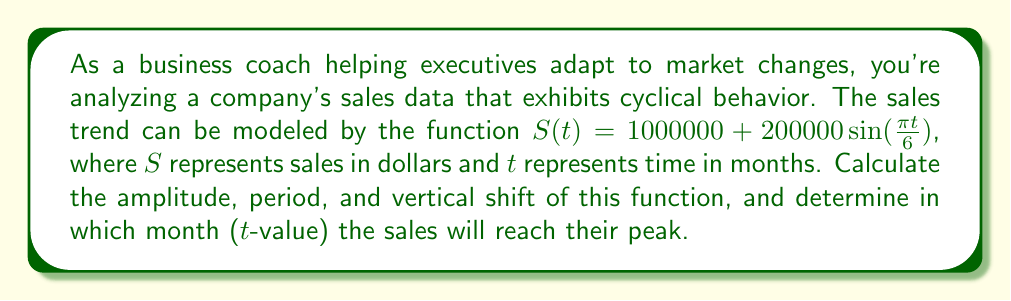Give your solution to this math problem. To analyze this cyclical business trend, we need to break down the sine function and identify its key components:

1. Amplitude:
The amplitude is the maximum deviation from the middle of the cycle. In the function $S(t) = 1000000 + 200000 \sin(\frac{\pi t}{6})$, the amplitude is $200000.

2. Period:
The period is the length of one complete cycle. For a sine function in the form $\sin(bx)$, the period is given by $\frac{2\pi}{|b|}$.
Here, $b = \frac{\pi}{6}$, so the period is:
$$\frac{2\pi}{|\frac{\pi}{6}|} = \frac{2\pi}{\frac{\pi}{6}} = 2 \cdot 6 = 12 \text{ months}$$

3. Vertical shift:
The vertical shift is the constant term added to the sine function. In this case, it's $1000000.

4. Peak sales:
To find when sales reach their peak, we need to determine when $\sin(\frac{\pi t}{6})$ equals 1, its maximum value.
This occurs when $\frac{\pi t}{6} = \frac{\pi}{2}$ (or 90 degrees).

Solving for t:
$$\frac{\pi t}{6} = \frac{\pi}{2}$$
$$t = \frac{6 \cdot \frac{\pi}{2}}{\pi} = 3 \text{ months}$$

Therefore, sales will reach their peak every 3 months (and every 15 months, 27 months, etc., due to the 12-month period).
Answer: Amplitude: $200000
Period: 12 months
Vertical shift: $1000000
Peak sales occur at t = 3 months (and every 12 months thereafter) 